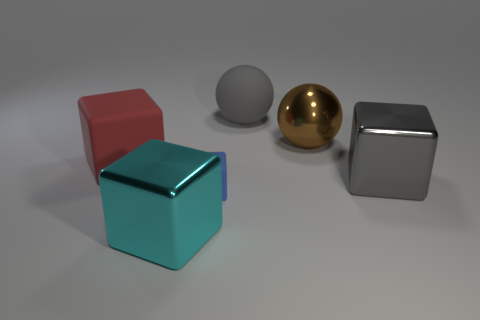Subtract all blue cubes. How many cubes are left? 3 Subtract all red blocks. How many blocks are left? 3 Subtract 1 balls. How many balls are left? 1 Subtract all red cubes. Subtract all green balls. How many cubes are left? 3 Subtract all blue balls. How many blue blocks are left? 1 Subtract all brown shiny balls. Subtract all cyan metal cubes. How many objects are left? 4 Add 3 small blue cubes. How many small blue cubes are left? 4 Add 3 big yellow rubber balls. How many big yellow rubber balls exist? 3 Add 1 cyan things. How many objects exist? 7 Subtract 0 purple cylinders. How many objects are left? 6 